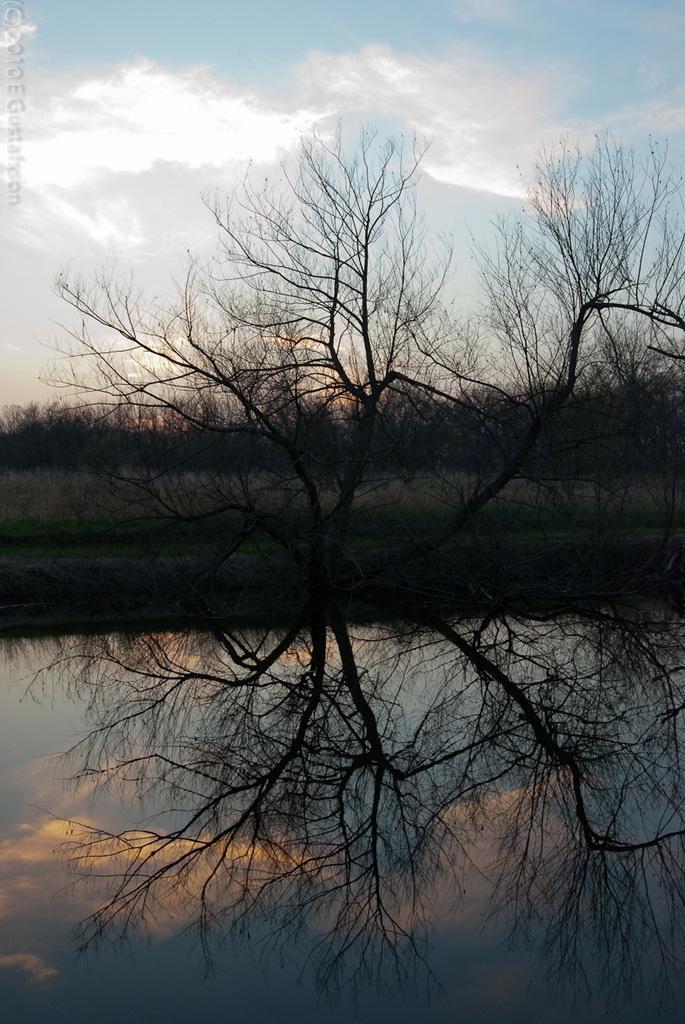Could you give a brief overview of what you see in this image? In this picture we can see water, trees, grass and in the background we can see the sky with clouds. 